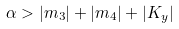Convert formula to latex. <formula><loc_0><loc_0><loc_500><loc_500>\alpha > | m _ { 3 } | + | m _ { 4 } | + | K _ { y } |</formula> 